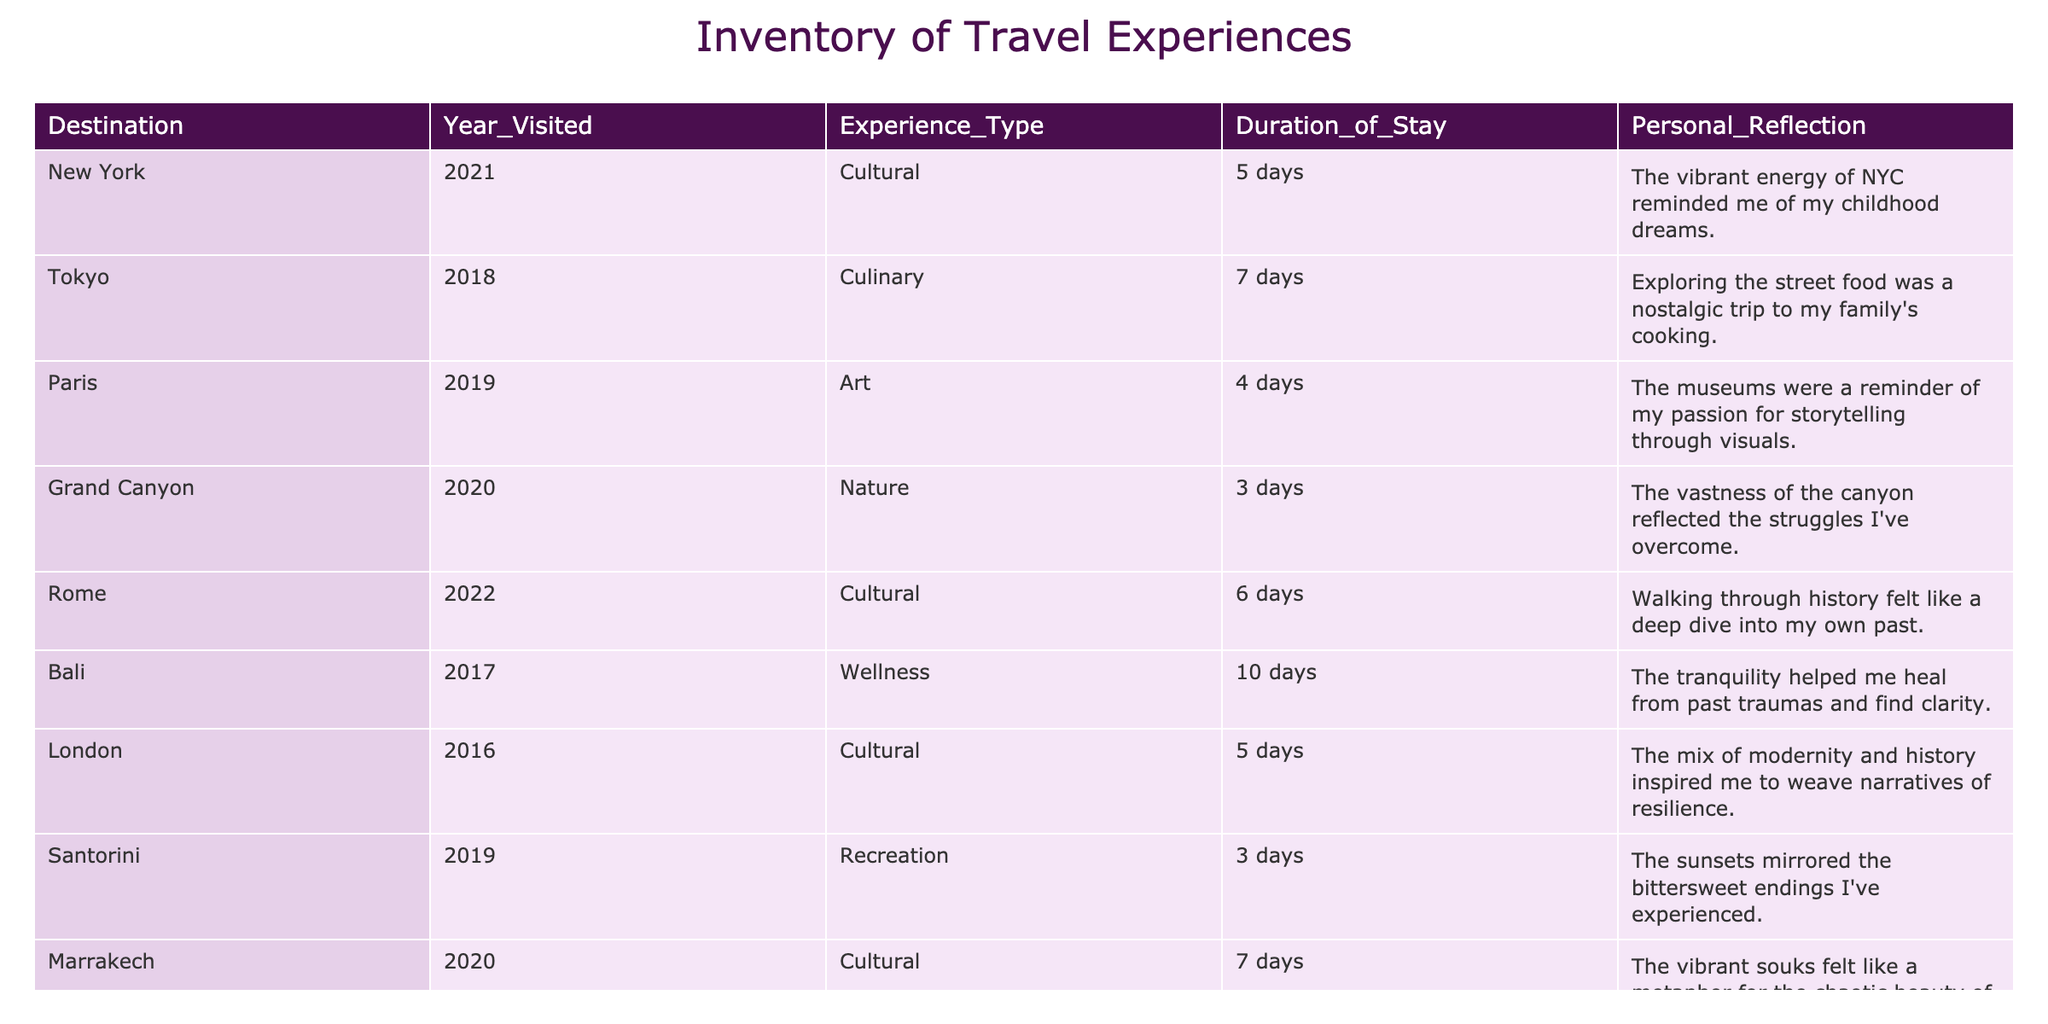What year was Bali visited? The table lists Bali under the 'Destination' column along with its 'Year_Visited.' According to the table, Bali was visited in 2017.
Answer: 2017 Which destination had the longest stay? By examining the 'Duration_of_Stay' column, we can see the lengths of stays for each destination. Bali had a 10-day stay, which is longer than any other entry.
Answer: Bali Was the experience in Paris focused on recreation? The 'Experience_Type' for Paris is listed as 'Art,' so it does not focus on recreation. Therefore, the statement is false.
Answer: No How many destinations were visited in 2020? The table can be analyzed by counting the occurrences of the year 2020 in the 'Year_Visited' column. There are two entries for that year (Grand Canyon and Marrakech).
Answer: 2 What is the average duration of stay for cultural experiences? First, we identify the cultural experiences: New York (5 days), Rome (6 days), London (5 days), and Marrakech (7 days). The total sum is 5 + 6 + 5 + 7 = 23 days. There are 4 cultural experiences, so we divide 23 by 4. The average duration is 23 / 4 = 5.75 days.
Answer: 5.75 Which destination's experience type was classified as wellness? The 'Experience_Type' column shows that Bali was classified as a wellness experience. Therefore, the destination with this classification is Bali.
Answer: Bali Is there a destination visited in 2021 that focuses on nature? In the 'Experience_Type' column, Vancouver is associated with nature for the year 2021, making the statement true.
Answer: Yes Which year had the most destinations listed? To find the year with the most entries, we can tally the counts from the 'Year_Visited' column. The counts show that 2020 has 2 entries (Grand Canyon and Marrakech), while the other years have only 1 entry each. Hence, 2020 has the most destinations listed.
Answer: 2020 